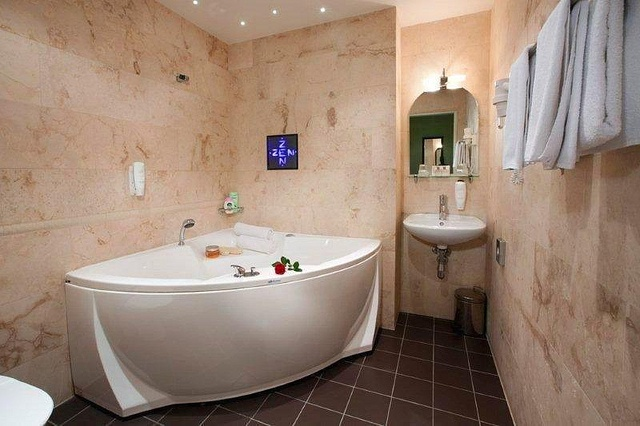Describe the objects in this image and their specific colors. I can see sink in gray, lightgray, and darkgray tones and toilet in gray, lightgray, darkgray, and black tones in this image. 